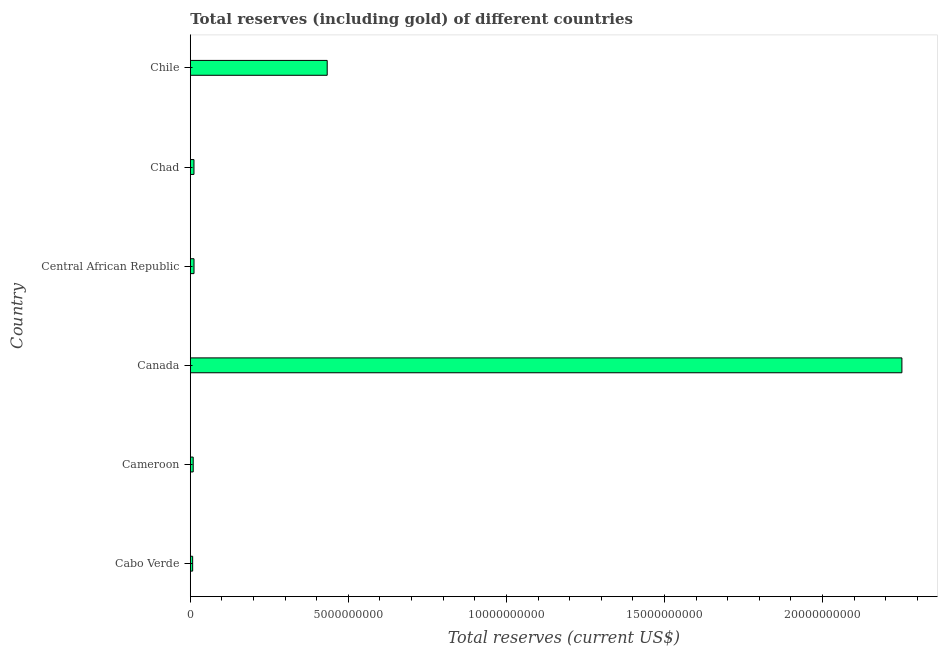Does the graph contain grids?
Keep it short and to the point. No. What is the title of the graph?
Make the answer very short. Total reserves (including gold) of different countries. What is the label or title of the X-axis?
Offer a very short reply. Total reserves (current US$). What is the total reserves (including gold) in Cabo Verde?
Offer a very short reply. 7.47e+07. Across all countries, what is the maximum total reserves (including gold)?
Ensure brevity in your answer.  2.25e+1. Across all countries, what is the minimum total reserves (including gold)?
Make the answer very short. 7.47e+07. In which country was the total reserves (including gold) maximum?
Your answer should be very brief. Canada. In which country was the total reserves (including gold) minimum?
Give a very brief answer. Cabo Verde. What is the sum of the total reserves (including gold)?
Make the answer very short. 2.72e+1. What is the difference between the total reserves (including gold) in Canada and Chad?
Keep it short and to the point. 2.24e+1. What is the average total reserves (including gold) per country?
Keep it short and to the point. 4.54e+09. What is the median total reserves (including gold)?
Offer a very short reply. 1.17e+08. In how many countries, is the total reserves (including gold) greater than 21000000000 US$?
Provide a succinct answer. 1. What is the ratio of the total reserves (including gold) in Central African Republic to that in Chile?
Make the answer very short. 0.03. Is the total reserves (including gold) in Cameroon less than that in Canada?
Your answer should be compact. Yes. What is the difference between the highest and the second highest total reserves (including gold)?
Keep it short and to the point. 1.82e+1. Is the sum of the total reserves (including gold) in Central African Republic and Chile greater than the maximum total reserves (including gold) across all countries?
Keep it short and to the point. No. What is the difference between the highest and the lowest total reserves (including gold)?
Your answer should be compact. 2.24e+1. In how many countries, is the total reserves (including gold) greater than the average total reserves (including gold) taken over all countries?
Offer a terse response. 1. Are all the bars in the graph horizontal?
Make the answer very short. Yes. How many countries are there in the graph?
Your response must be concise. 6. Are the values on the major ticks of X-axis written in scientific E-notation?
Your answer should be compact. No. What is the Total reserves (current US$) in Cabo Verde?
Offer a terse response. 7.47e+07. What is the Total reserves (current US$) in Cameroon?
Your response must be concise. 9.19e+07. What is the Total reserves (current US$) of Canada?
Make the answer very short. 2.25e+1. What is the Total reserves (current US$) of Central African Republic?
Provide a succinct answer. 1.18e+08. What is the Total reserves (current US$) in Chad?
Give a very brief answer. 1.16e+08. What is the Total reserves (current US$) of Chile?
Your answer should be very brief. 4.33e+09. What is the difference between the Total reserves (current US$) in Cabo Verde and Cameroon?
Offer a very short reply. -1.72e+07. What is the difference between the Total reserves (current US$) in Cabo Verde and Canada?
Provide a short and direct response. -2.24e+1. What is the difference between the Total reserves (current US$) in Cabo Verde and Central African Republic?
Your answer should be very brief. -4.28e+07. What is the difference between the Total reserves (current US$) in Cabo Verde and Chad?
Your response must be concise. -4.14e+07. What is the difference between the Total reserves (current US$) in Cabo Verde and Chile?
Offer a terse response. -4.26e+09. What is the difference between the Total reserves (current US$) in Cameroon and Canada?
Ensure brevity in your answer.  -2.24e+1. What is the difference between the Total reserves (current US$) in Cameroon and Central African Republic?
Offer a terse response. -2.56e+07. What is the difference between the Total reserves (current US$) in Cameroon and Chad?
Provide a short and direct response. -2.43e+07. What is the difference between the Total reserves (current US$) in Cameroon and Chile?
Keep it short and to the point. -4.24e+09. What is the difference between the Total reserves (current US$) in Canada and Central African Republic?
Your response must be concise. 2.24e+1. What is the difference between the Total reserves (current US$) in Canada and Chad?
Make the answer very short. 2.24e+1. What is the difference between the Total reserves (current US$) in Canada and Chile?
Offer a terse response. 1.82e+1. What is the difference between the Total reserves (current US$) in Central African Republic and Chad?
Ensure brevity in your answer.  1.33e+06. What is the difference between the Total reserves (current US$) in Central African Republic and Chile?
Your response must be concise. -4.21e+09. What is the difference between the Total reserves (current US$) in Chad and Chile?
Provide a short and direct response. -4.21e+09. What is the ratio of the Total reserves (current US$) in Cabo Verde to that in Cameroon?
Keep it short and to the point. 0.81. What is the ratio of the Total reserves (current US$) in Cabo Verde to that in Canada?
Provide a short and direct response. 0. What is the ratio of the Total reserves (current US$) in Cabo Verde to that in Central African Republic?
Your answer should be compact. 0.64. What is the ratio of the Total reserves (current US$) in Cabo Verde to that in Chad?
Ensure brevity in your answer.  0.64. What is the ratio of the Total reserves (current US$) in Cabo Verde to that in Chile?
Provide a short and direct response. 0.02. What is the ratio of the Total reserves (current US$) in Cameroon to that in Canada?
Provide a succinct answer. 0. What is the ratio of the Total reserves (current US$) in Cameroon to that in Central African Republic?
Your response must be concise. 0.78. What is the ratio of the Total reserves (current US$) in Cameroon to that in Chad?
Keep it short and to the point. 0.79. What is the ratio of the Total reserves (current US$) in Cameroon to that in Chile?
Provide a succinct answer. 0.02. What is the ratio of the Total reserves (current US$) in Canada to that in Central African Republic?
Your answer should be compact. 191.56. What is the ratio of the Total reserves (current US$) in Canada to that in Chad?
Offer a very short reply. 193.76. What is the ratio of the Total reserves (current US$) in Canada to that in Chile?
Give a very brief answer. 5.2. What is the ratio of the Total reserves (current US$) in Central African Republic to that in Chad?
Your answer should be very brief. 1.01. What is the ratio of the Total reserves (current US$) in Central African Republic to that in Chile?
Give a very brief answer. 0.03. What is the ratio of the Total reserves (current US$) in Chad to that in Chile?
Keep it short and to the point. 0.03. 